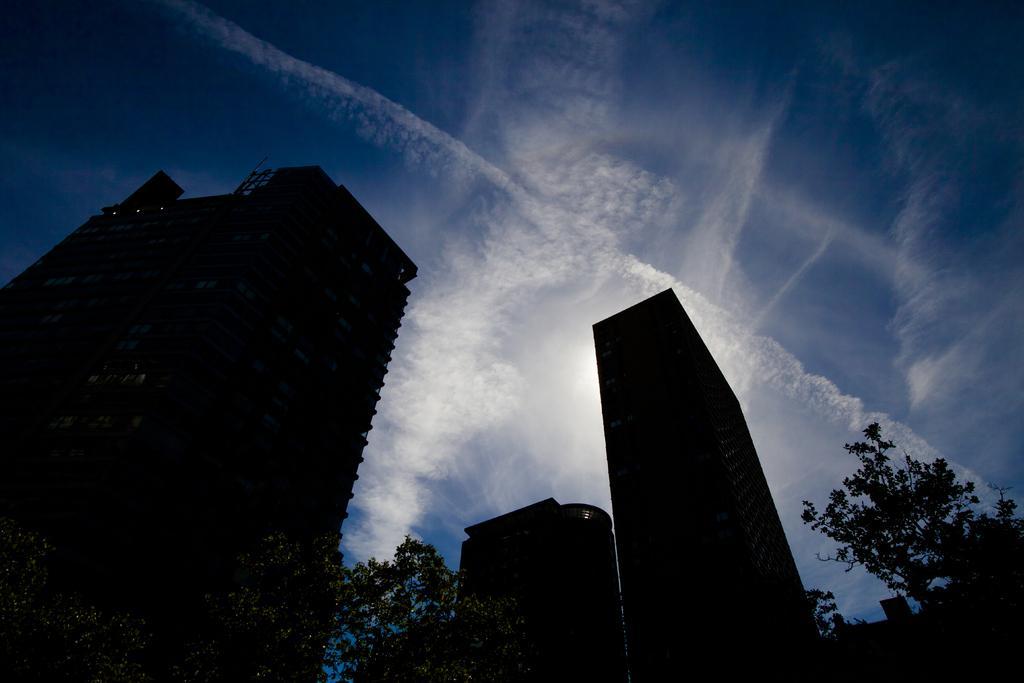Can you describe this image briefly? There are buildings and trees. In the background there is sky with clouds. 